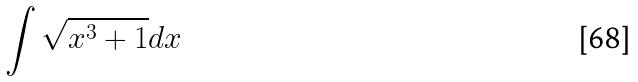<formula> <loc_0><loc_0><loc_500><loc_500>\int \sqrt { x ^ { 3 } + 1 } d x</formula> 